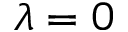Convert formula to latex. <formula><loc_0><loc_0><loc_500><loc_500>\lambda = 0</formula> 